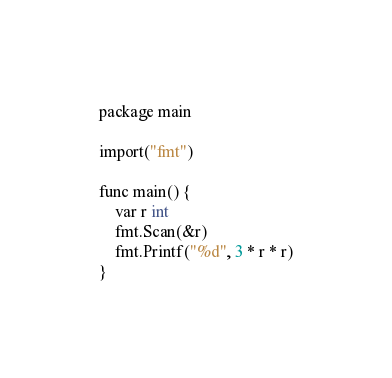<code> <loc_0><loc_0><loc_500><loc_500><_Go_>package main

import("fmt")

func main() {
	var r int
	fmt.Scan(&r)
	fmt.Printf("%d", 3 * r * r)
}</code> 